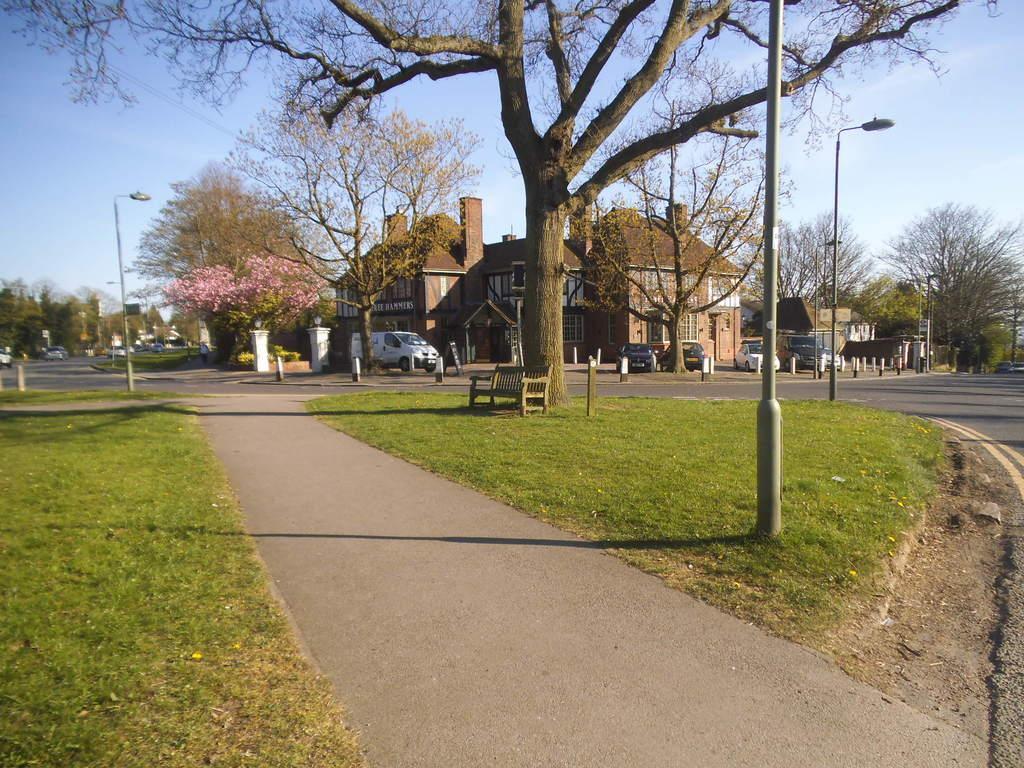Please provide a concise description of this image. We can see grass, lights on poles, bench, tree and road. In the background we can see buildings, vehicles, trees and sky. 